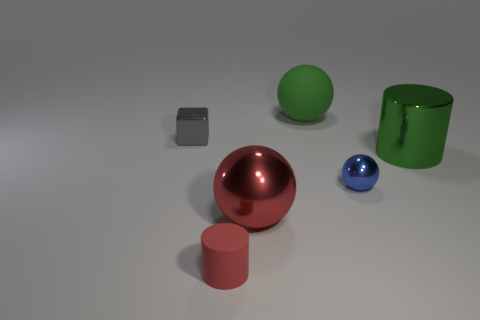What material do the objects in the image appear to be made of? The objects in the image seem to have a glossy, reflective surface, suggesting they could be made of materials like polished metal or plastic, each enhancing the object's luster under the lighting conditions. 